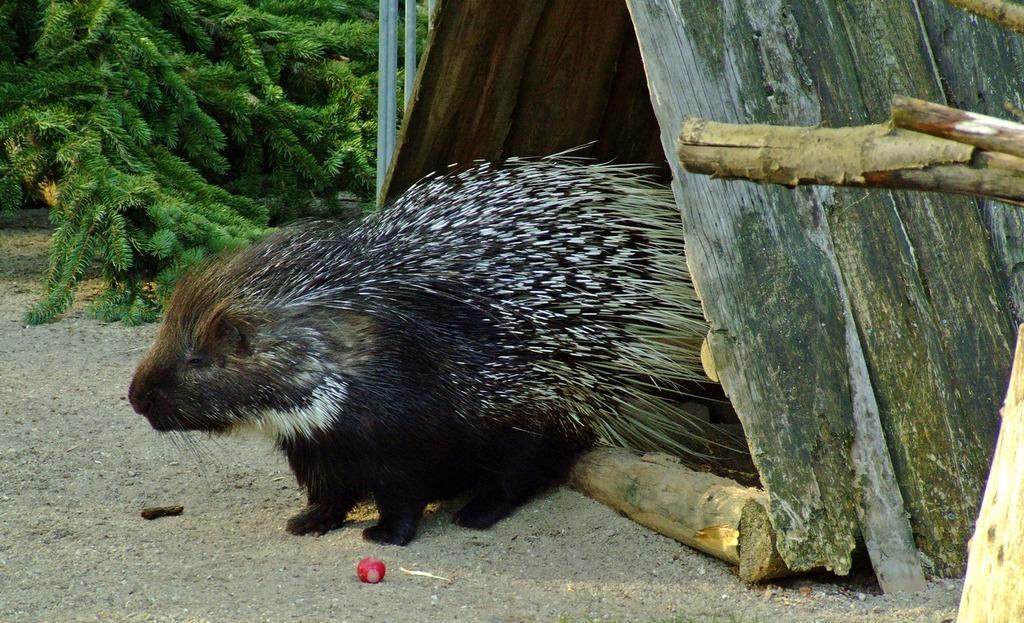Describe this image in one or two sentences. In this image we can see an animal, pet house, ground, wooden sticks, rods, branches, and an object. 